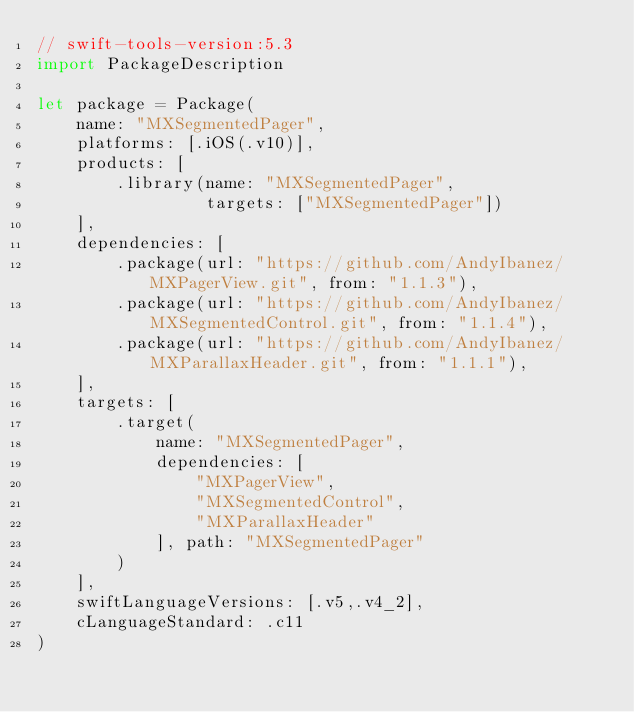<code> <loc_0><loc_0><loc_500><loc_500><_Swift_>// swift-tools-version:5.3
import PackageDescription

let package = Package(
    name: "MXSegmentedPager",
    platforms: [.iOS(.v10)],
    products: [
        .library(name: "MXSegmentedPager",
                 targets: ["MXSegmentedPager"])
    ],
    dependencies: [
        .package(url: "https://github.com/AndyIbanez/MXPagerView.git", from: "1.1.3"),
        .package(url: "https://github.com/AndyIbanez/MXSegmentedControl.git", from: "1.1.4"),
        .package(url: "https://github.com/AndyIbanez/MXParallaxHeader.git", from: "1.1.1"),
    ],
    targets: [
        .target(
            name: "MXSegmentedPager",
            dependencies: [
                "MXPagerView",
                "MXSegmentedControl",
                "MXParallaxHeader"
            ], path: "MXSegmentedPager"
        )
    ],
    swiftLanguageVersions: [.v5,.v4_2],
    cLanguageStandard: .c11
)
</code> 